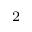<formula> <loc_0><loc_0><loc_500><loc_500>_ { 2 }</formula> 